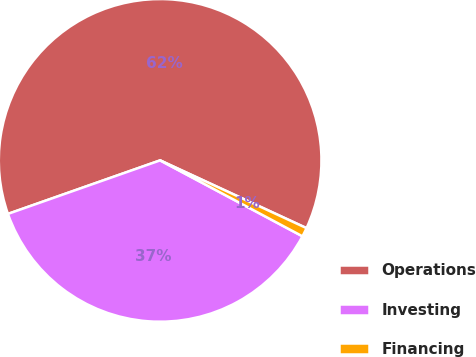Convert chart to OTSL. <chart><loc_0><loc_0><loc_500><loc_500><pie_chart><fcel>Operations<fcel>Investing<fcel>Financing<nl><fcel>62.28%<fcel>36.82%<fcel>0.9%<nl></chart> 